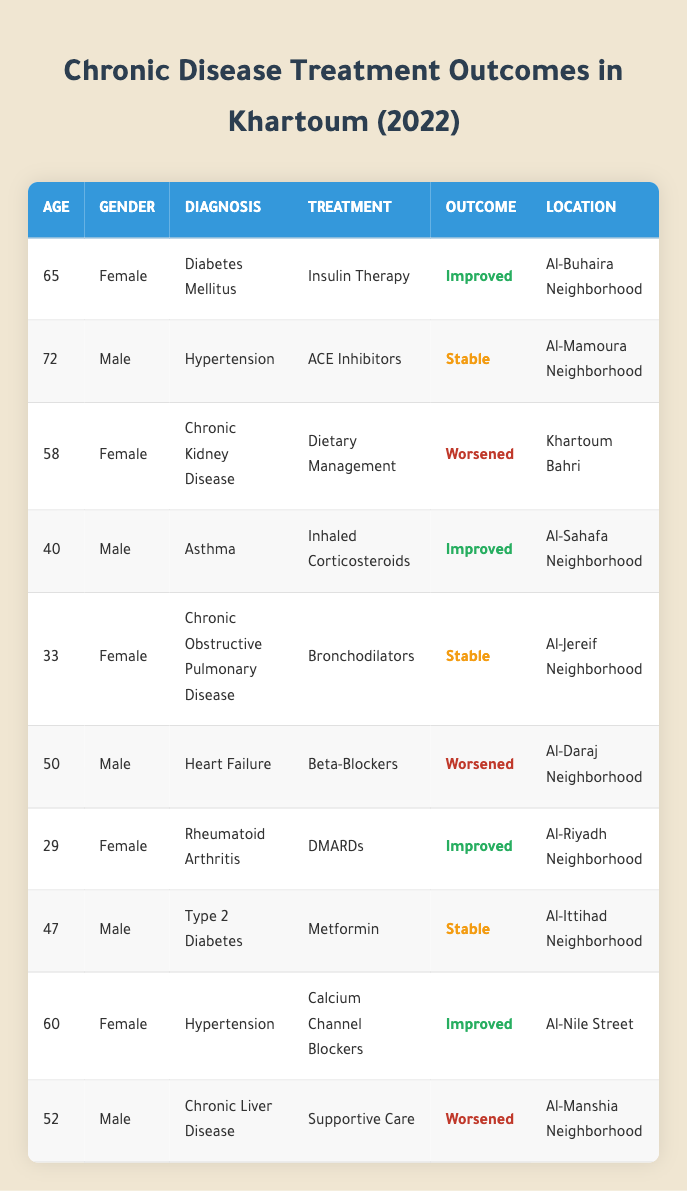What is the age of the patient diagnosed with Chronic Kidney Disease? The patient with Chronic Kidney Disease is listed in row three. The age mentioned in that row is 58.
Answer: 58 How many patients received DMARDs as treatment? In the table, we look for the treatment "DMARDs." There is one patient (patient_id 7) who received it, as observed in the corresponding row.
Answer: 1 What percentage of patients improved after treatment? There are 10 patients total. The patients with "Improved" outcomes are 4 (rows 1, 4, 9, and 7). To find the percentage, (4/10) * 100 = 40%.
Answer: 40% True or False: All patients receiving Bronchodilators reported improved outcomes. Only one patient is listed receiving Bronchodilators (patient_id 5), and that patient's outcome is "Stable," not "Improved." Therefore, it is false that all patients in this treatment category improved.
Answer: False What is the average age of patients who had stable outcomes? From the table, the stable outcome patients are 2 (patient_id 2, 5, and 8) with ages: 72, 33, and 47. Their total age is 72 + 33 + 47 = 152. There are 3 patients, so the average is 152/3 ≈ 50.67.
Answer: 50.67 How many males experienced a worsened outcome? We examine the rows for male patients with "Worsened" outcomes, which are from patient_id 6 and 10. Thus, there are two males in this category.
Answer: 2 What is the diagnosis of the patient from Al-Daraj Neighborhood? The row corresponding to Al-Daraj Neighborhood lists that the patient has "Heart Failure" as their diagnosis.
Answer: Heart Failure Which treatment was associated with the best outcome based on the table? "Improved" is categorized with treatments: Insulin Therapy, Inhaled Corticosteroids, DMARDs, and Calcium Channel Blockers. The best outcome listed is with these treatments, which all led to patient improvements.
Answer: Insulin Therapy, Inhaled Corticosteroids, DMARDs, Calcium Channel Blockers In total, how many different diagnoses are represented in the table? By examining the unique diagnoses listed (Diabetes Mellitus, Hypertension, Chronic Kidney Disease, Asthma, Chronic Obstructive Pulmonary Disease, Heart Failure, Rheumatoid Arthritis, Type 2 Diabetes, and Chronic Liver Disease), we find there are 9 distinct diagnoses.
Answer: 9 What location has a patient who experienced a Worsened outcome? The patients with worsened outcomes are in Khartoum Bahri (patient_id 3), Al-Daraj Neighborhood (patient_id 6), and Al-Manshia Neighborhood (patient_id 10). Thus, the locations are Khartoum Bahri, Al-Daraj, and Al-Manshia Neighborhoods.
Answer: Khartoum Bahri, Al-Daraj Neighborhood, Al-Manshia Neighborhood 